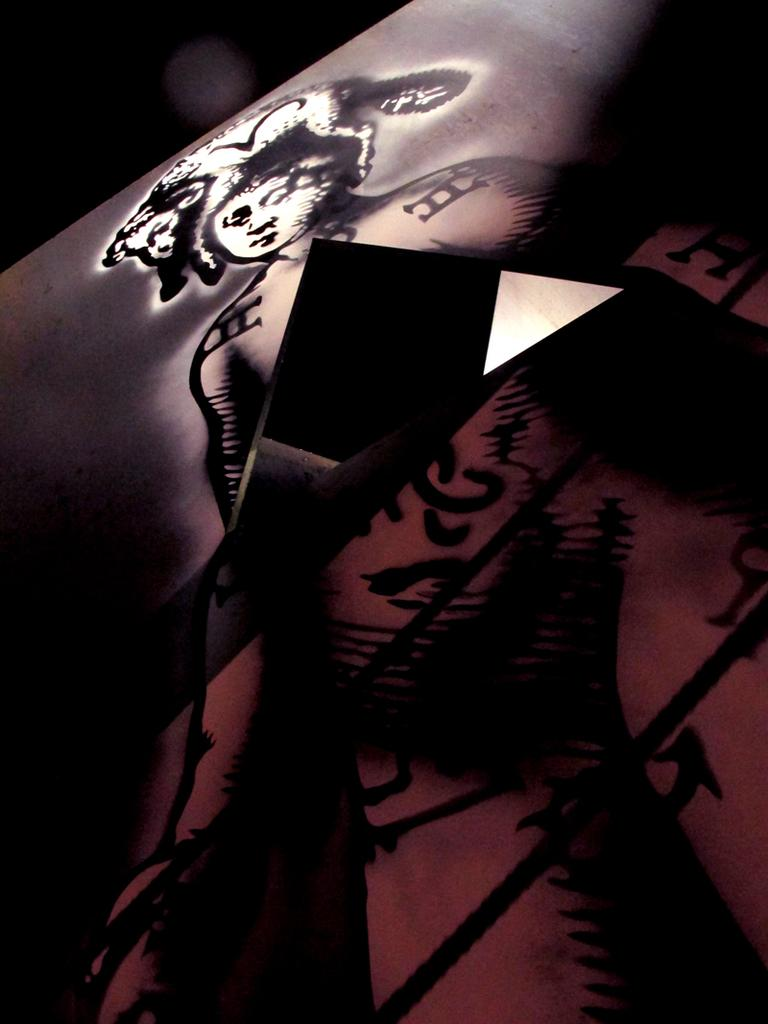What is the main object in the image? There is a board in the image. What can be observed on the surface of the board? The board has designs on it and a picture. Is there any specific shape cut into the board? Yes, there is a triangular cut in the middle of the board. Where is the vest stored in the image? There is no vest present in the image. What type of attraction can be seen in the background of the image? There is no attraction visible in the image; it only features a board with designs, a picture, and a triangular cut. 